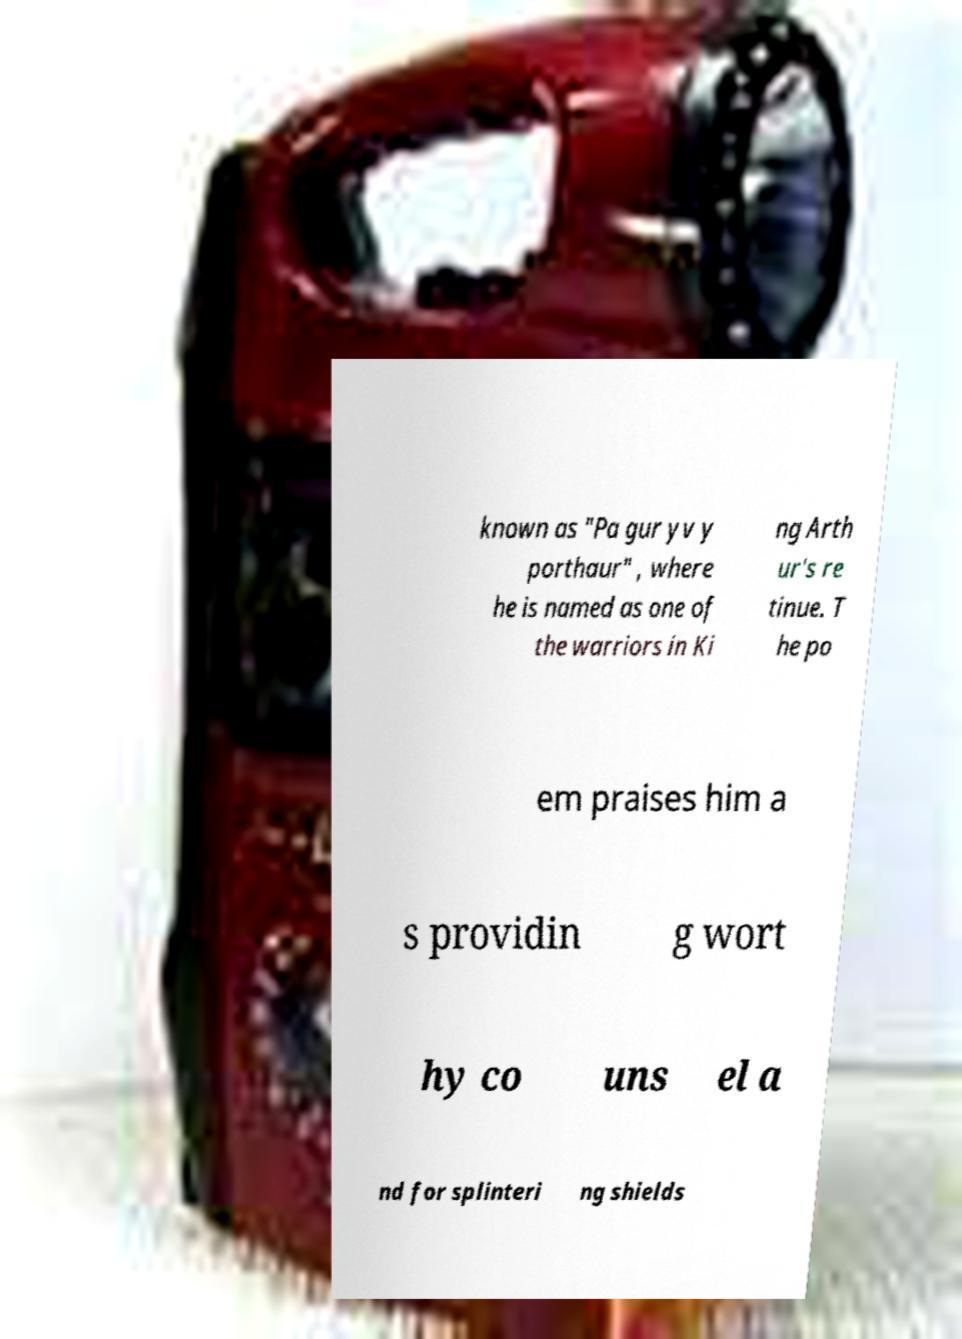There's text embedded in this image that I need extracted. Can you transcribe it verbatim? known as "Pa gur yv y porthaur" , where he is named as one of the warriors in Ki ng Arth ur's re tinue. T he po em praises him a s providin g wort hy co uns el a nd for splinteri ng shields 